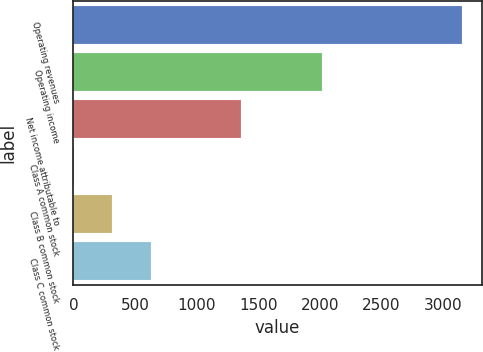<chart> <loc_0><loc_0><loc_500><loc_500><bar_chart><fcel>Operating revenues<fcel>Operating income<fcel>Net income attributable to<fcel>Class A common stock<fcel>Class B common stock<fcel>Class C common stock<nl><fcel>3155<fcel>2020<fcel>1360<fcel>0.54<fcel>315.99<fcel>631.44<nl></chart> 